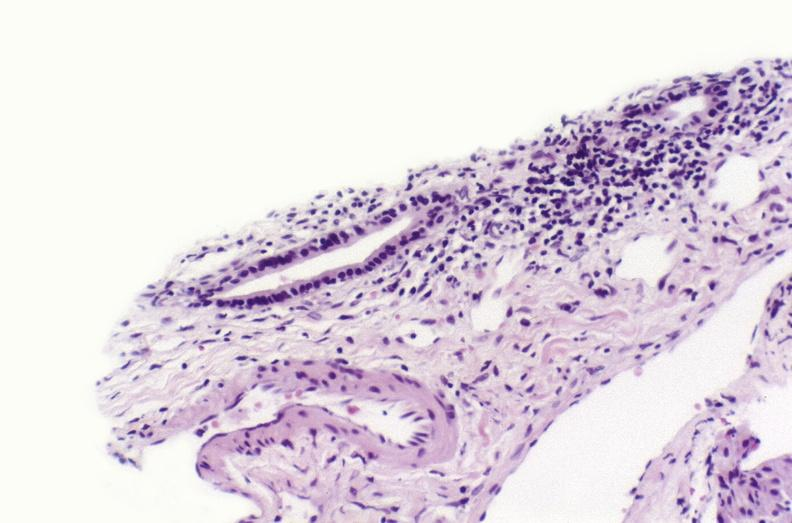s hepatobiliary present?
Answer the question using a single word or phrase. Yes 